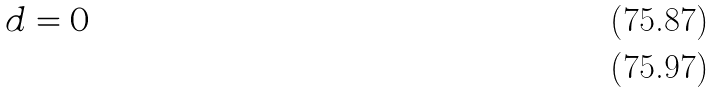Convert formula to latex. <formula><loc_0><loc_0><loc_500><loc_500>d = 0 \\</formula> 